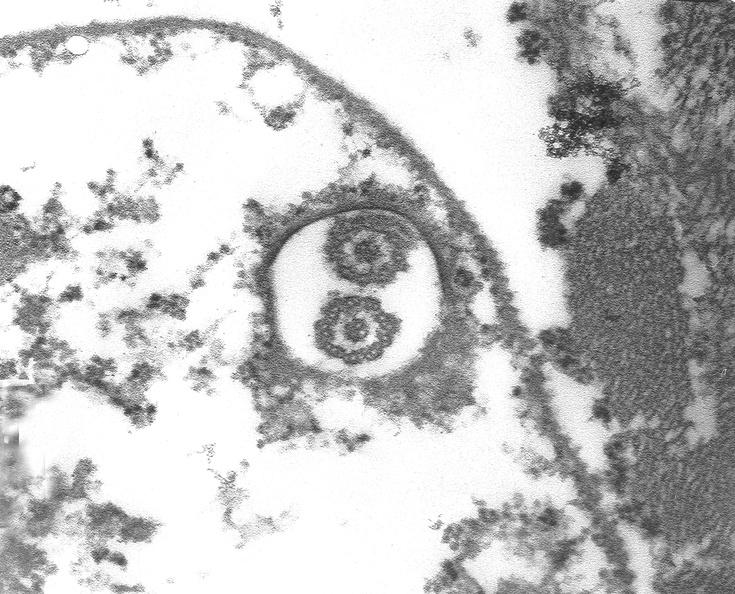does this image show chagas disease, acute, trypanasoma cruzi?
Answer the question using a single word or phrase. Yes 